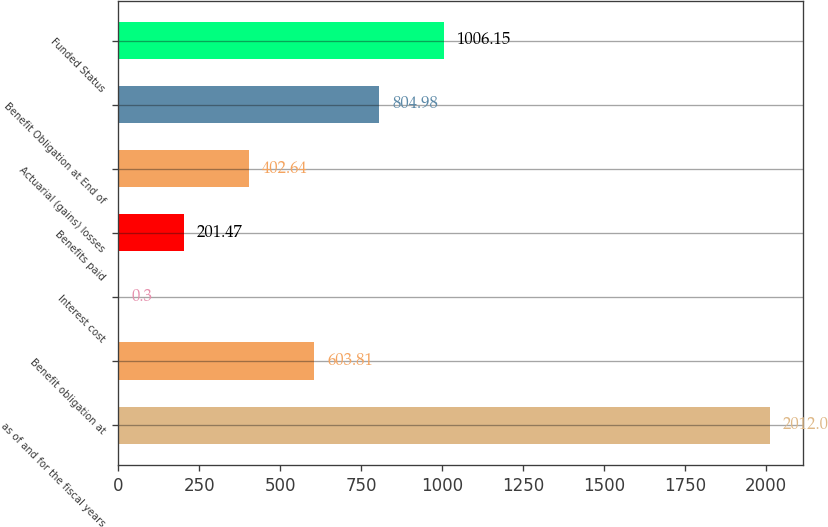Convert chart to OTSL. <chart><loc_0><loc_0><loc_500><loc_500><bar_chart><fcel>as of and for the fiscal years<fcel>Benefit obligation at<fcel>Interest cost<fcel>Benefits paid<fcel>Actuarial (gains) losses<fcel>Benefit Obligation at End of<fcel>Funded Status<nl><fcel>2012<fcel>603.81<fcel>0.3<fcel>201.47<fcel>402.64<fcel>804.98<fcel>1006.15<nl></chart> 